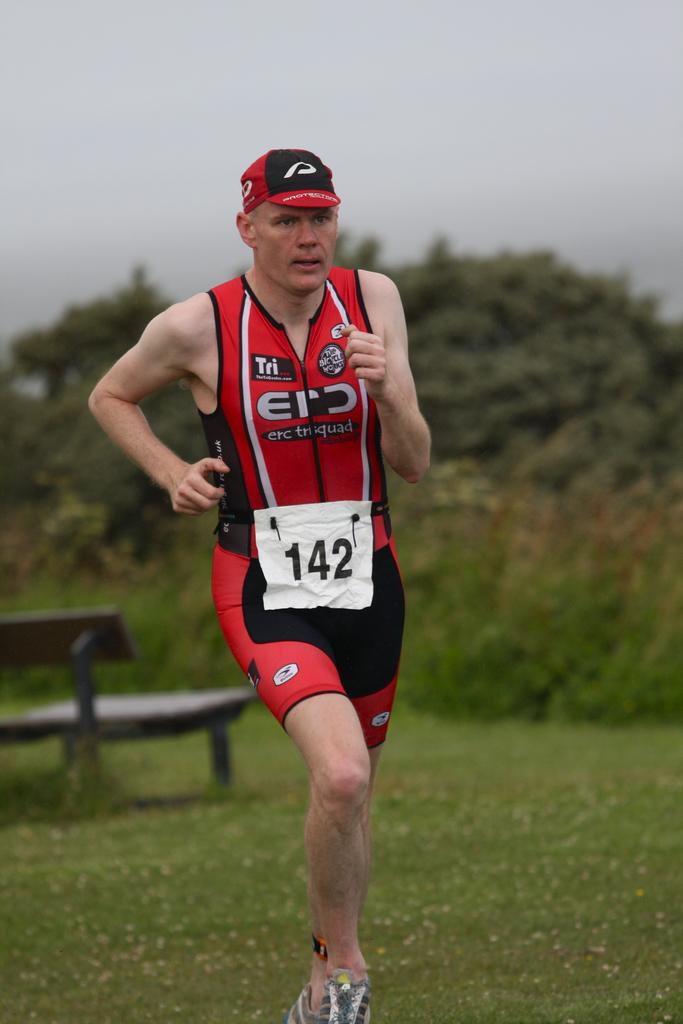What is this person's race number?
Offer a terse response. 142. What is the sponsor on the top left corner of the jersey?
Provide a succinct answer. Tri. 